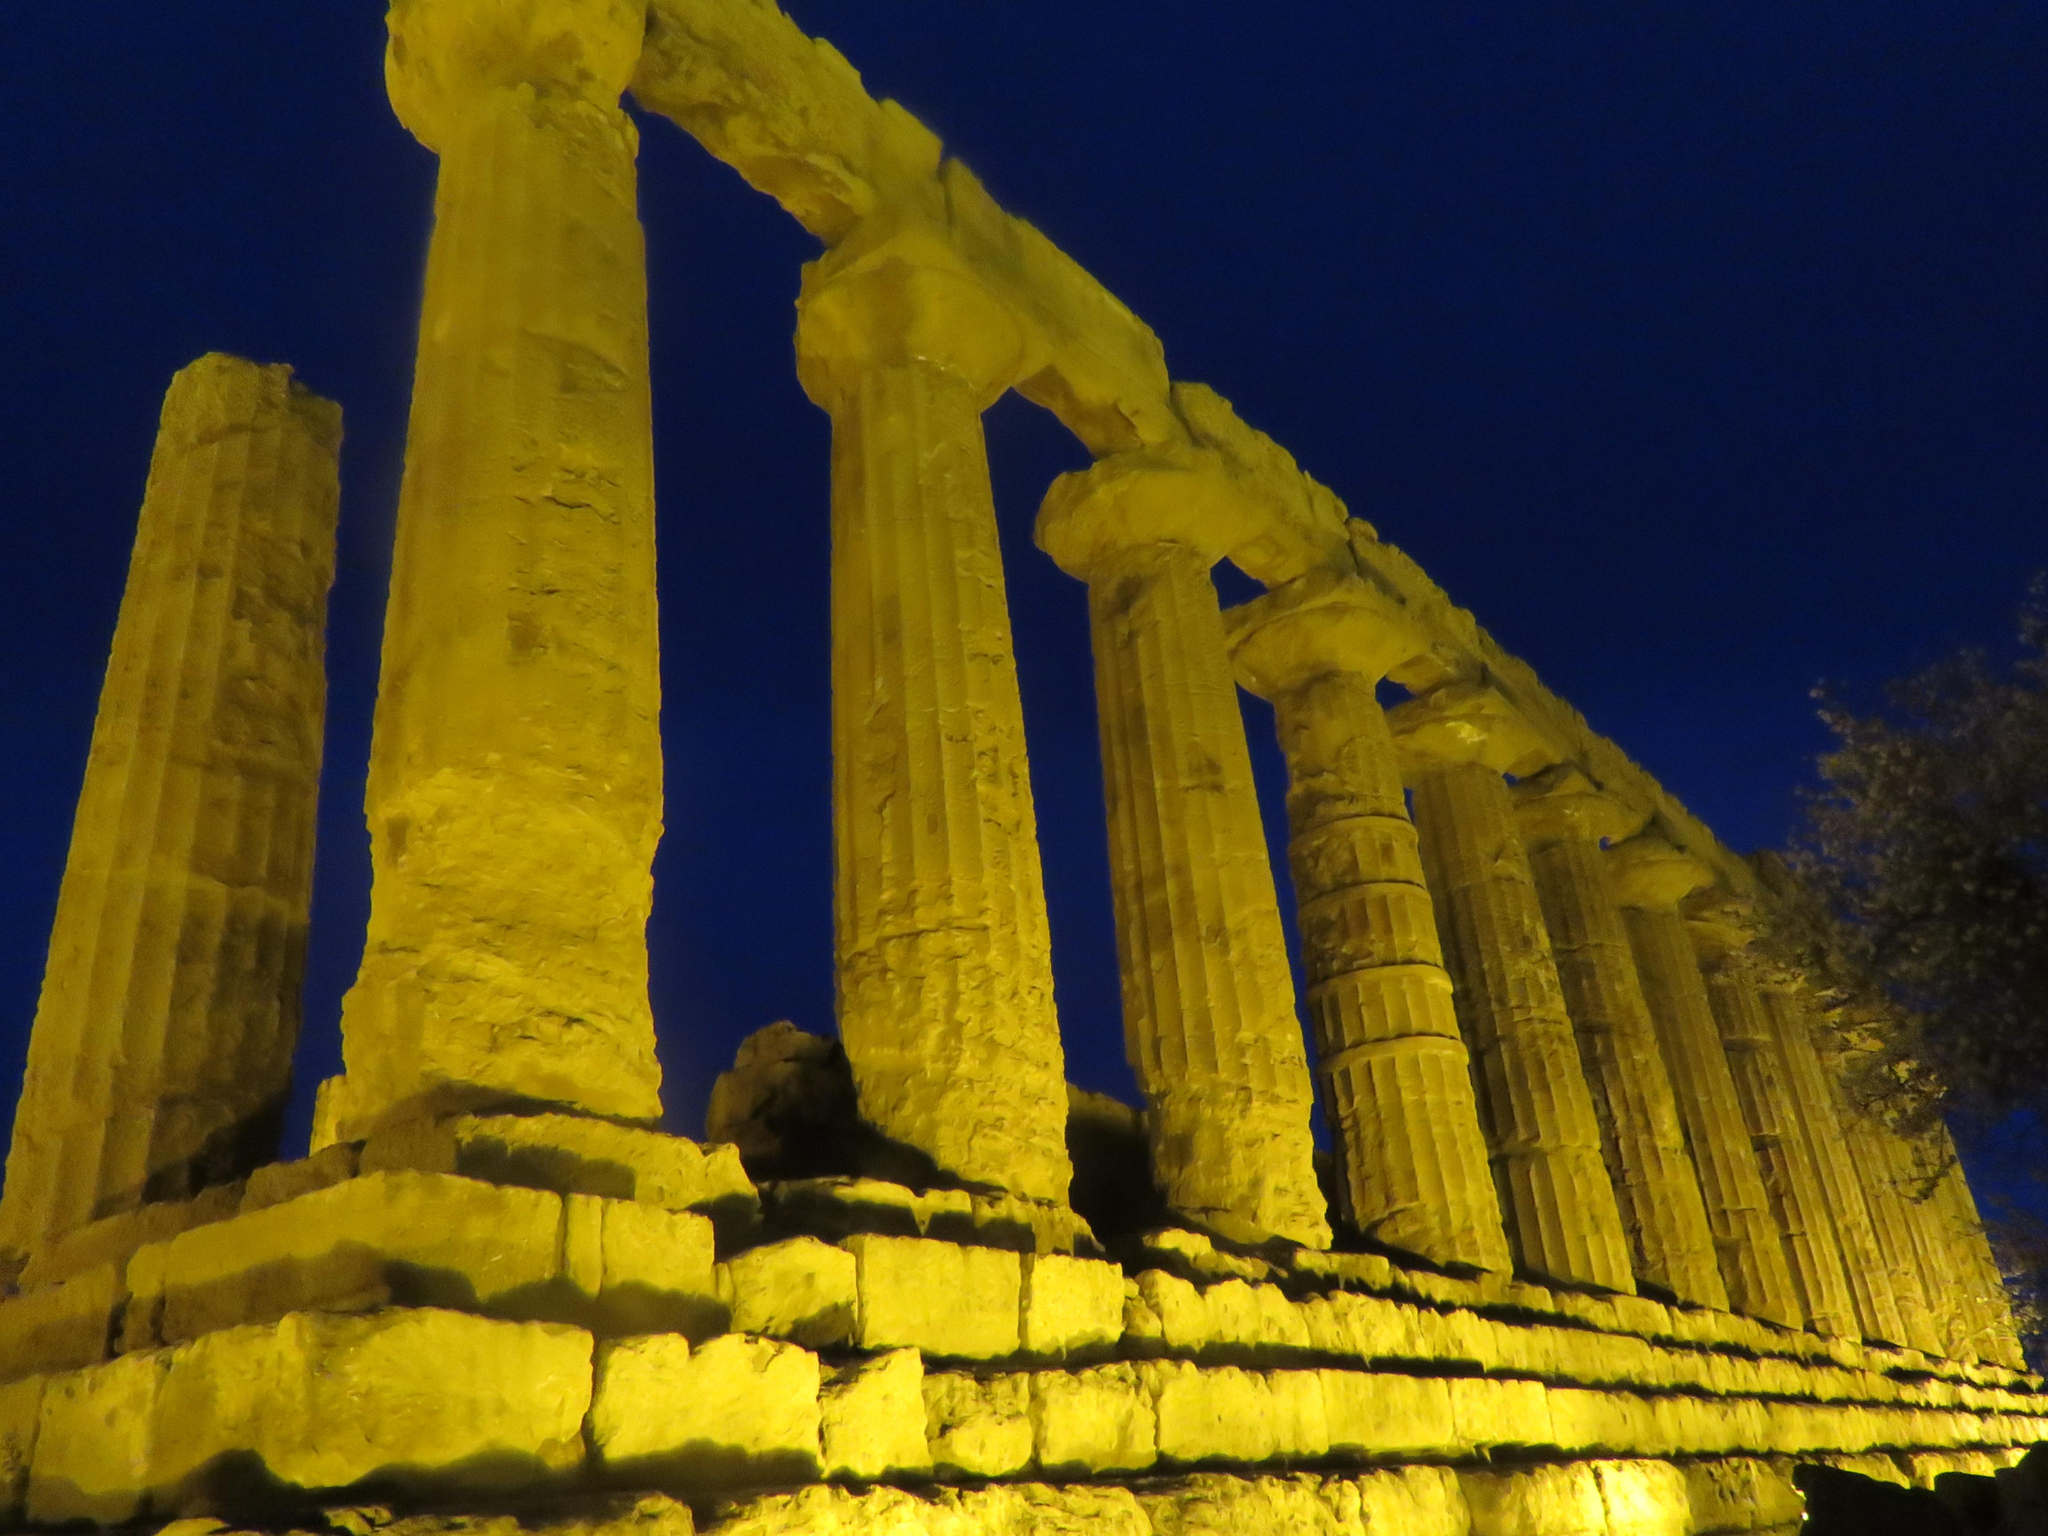What type of view is shown in the image? The image has an outside view. What architectural features can be seen in the foreground of the image? There are pillars in the foreground of the image. What part of the natural environment is visible in the background of the image? The sky is visible in the background of the image. Can you see any oranges growing on the trees in the image? There are no trees or oranges present in the image. What type of pencil can be seen being used by the person in the image? There is no person or pencil visible in the image. 